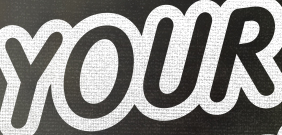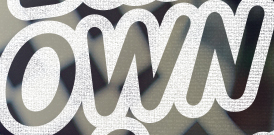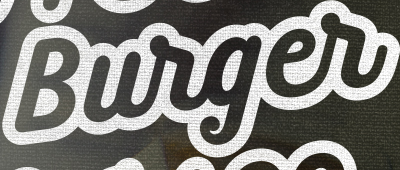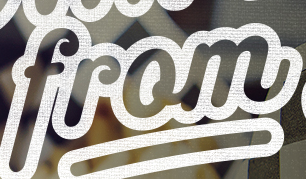What text is displayed in these images sequentially, separated by a semicolon? YOUR; OWN; Burger; from 